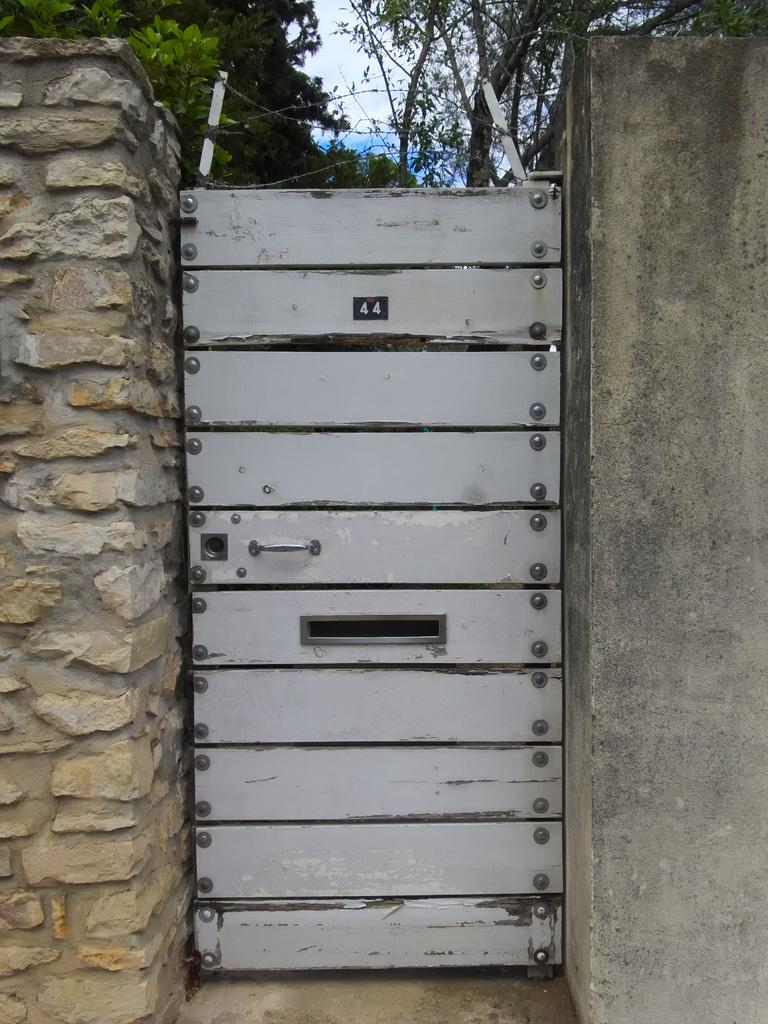What structure is present in the image? There is a door and a wall in the image. What can be seen in the background of the image? There are trees and the sky visible in the background of the image. How many geese are flying in the image? There are no geese present in the image. What type of government is depicted in the image? There is no depiction of a government in the image. 